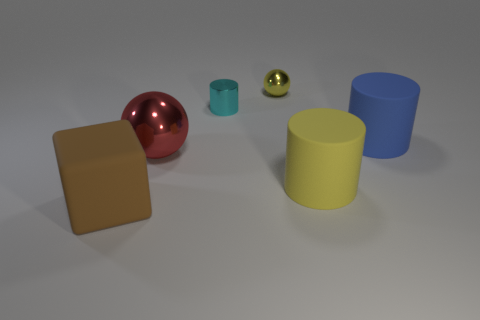Add 2 large rubber cylinders. How many objects exist? 8 Subtract all balls. How many objects are left? 4 Subtract all small brown balls. Subtract all metallic balls. How many objects are left? 4 Add 1 large blocks. How many large blocks are left? 2 Add 3 small cylinders. How many small cylinders exist? 4 Subtract 1 yellow balls. How many objects are left? 5 